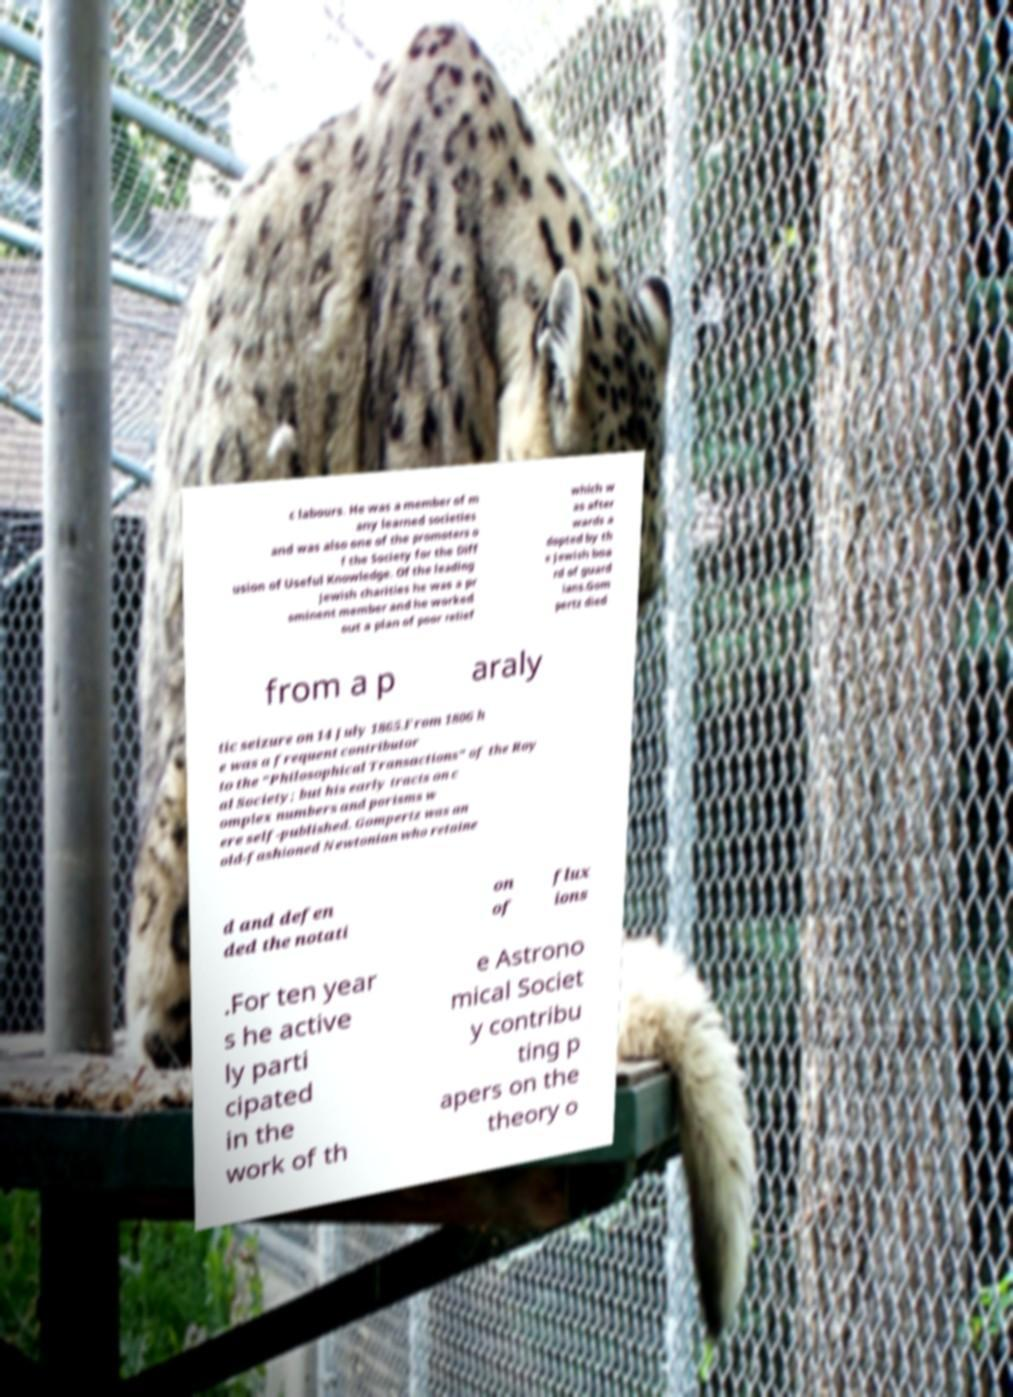For documentation purposes, I need the text within this image transcribed. Could you provide that? c labours. He was a member of m any learned societies and was also one of the promoters o f the Society for the Diff usion of Useful Knowledge. Of the leading Jewish charities he was a pr ominent member and he worked out a plan of poor relief which w as after wards a dopted by th e Jewish boa rd of guard ians.Gom pertz died from a p araly tic seizure on 14 July 1865.From 1806 h e was a frequent contributor to the "Philosophical Transactions" of the Roy al Society; but his early tracts on c omplex numbers and porisms w ere self-published. Gompertz was an old-fashioned Newtonian who retaine d and defen ded the notati on of flux ions .For ten year s he active ly parti cipated in the work of th e Astrono mical Societ y contribu ting p apers on the theory o 